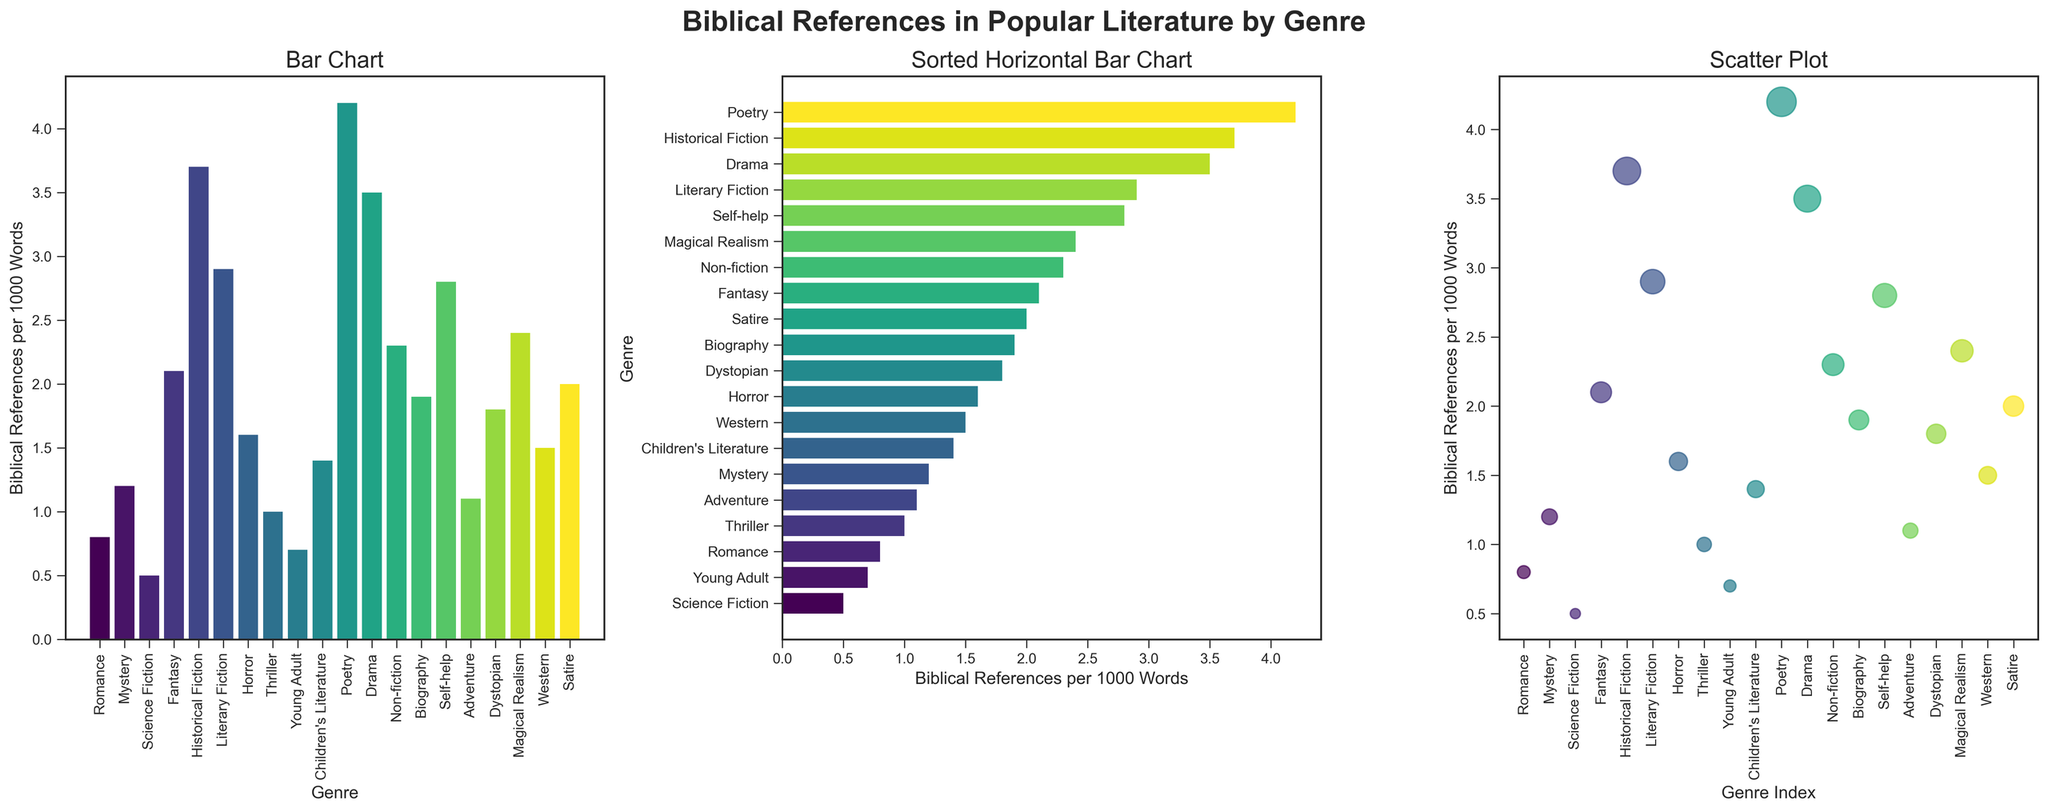What genre has the highest frequency of biblical references per 1000 words? Look at the bar heights in both bar plots. The highest bar represents Poetry. The exact value can be seen in the label or refer to the y-axis in the bar chart.
Answer: Poetry Which genre has fewer biblical references per 1000 words, Romance or Horror? Compare the heights of the bars corresponding to Romance and Horror. The bar for Romance is shorter than the one for Horror.
Answer: Romance How many genres have a frequency of biblical references per 1000 words greater than 2.0? Count the number of bars that exceed the value of 2.0 on the y-axis.
Answer: 9 By how much does Historical Fiction exceed Science Fiction in biblical references per 1000 words? Subtract the frequency value of Science Fiction from that of Historical Fiction. Historical Fiction has 3.7, and Science Fiction has 0.5. So, 3.7 - 0.5 = 3.2
Answer: 3.2 What is the average frequency of biblical references per 1000 words for the genres Poetry, Drama, and Non-fiction? Average is calculated by adding all values and dividing by the count. So, (4.2 + 3.5 + 2.3) / 3 = 10.0 / 3 ≈ 3.33
Answer: 3.33 Which genre is approximately in the middle in terms of biblical references per 1000 words when sorted? In the sorted horizontal bar chart, the middle genre visually corresponds to the genre at the midpoint in the list. Depending on an exact count (20 genres), look at the 10th and 11th on the sorted chart. Comparing the exact values might show which one is right in the middle.
Answer: Biography How does the frequency of biblical references in Western compare to Thriller? Compare the heights of the bars for Western and Thriller. Western has 1.5 and Thriller has 1.0, so Western is higher.
Answer: Western has higher Which genre stands out the most visually in the scatter plot? The largest and/or most prominent bubble represents the genre with the highest frequency of biblical references, which is Poetry.
Answer: Poetry 